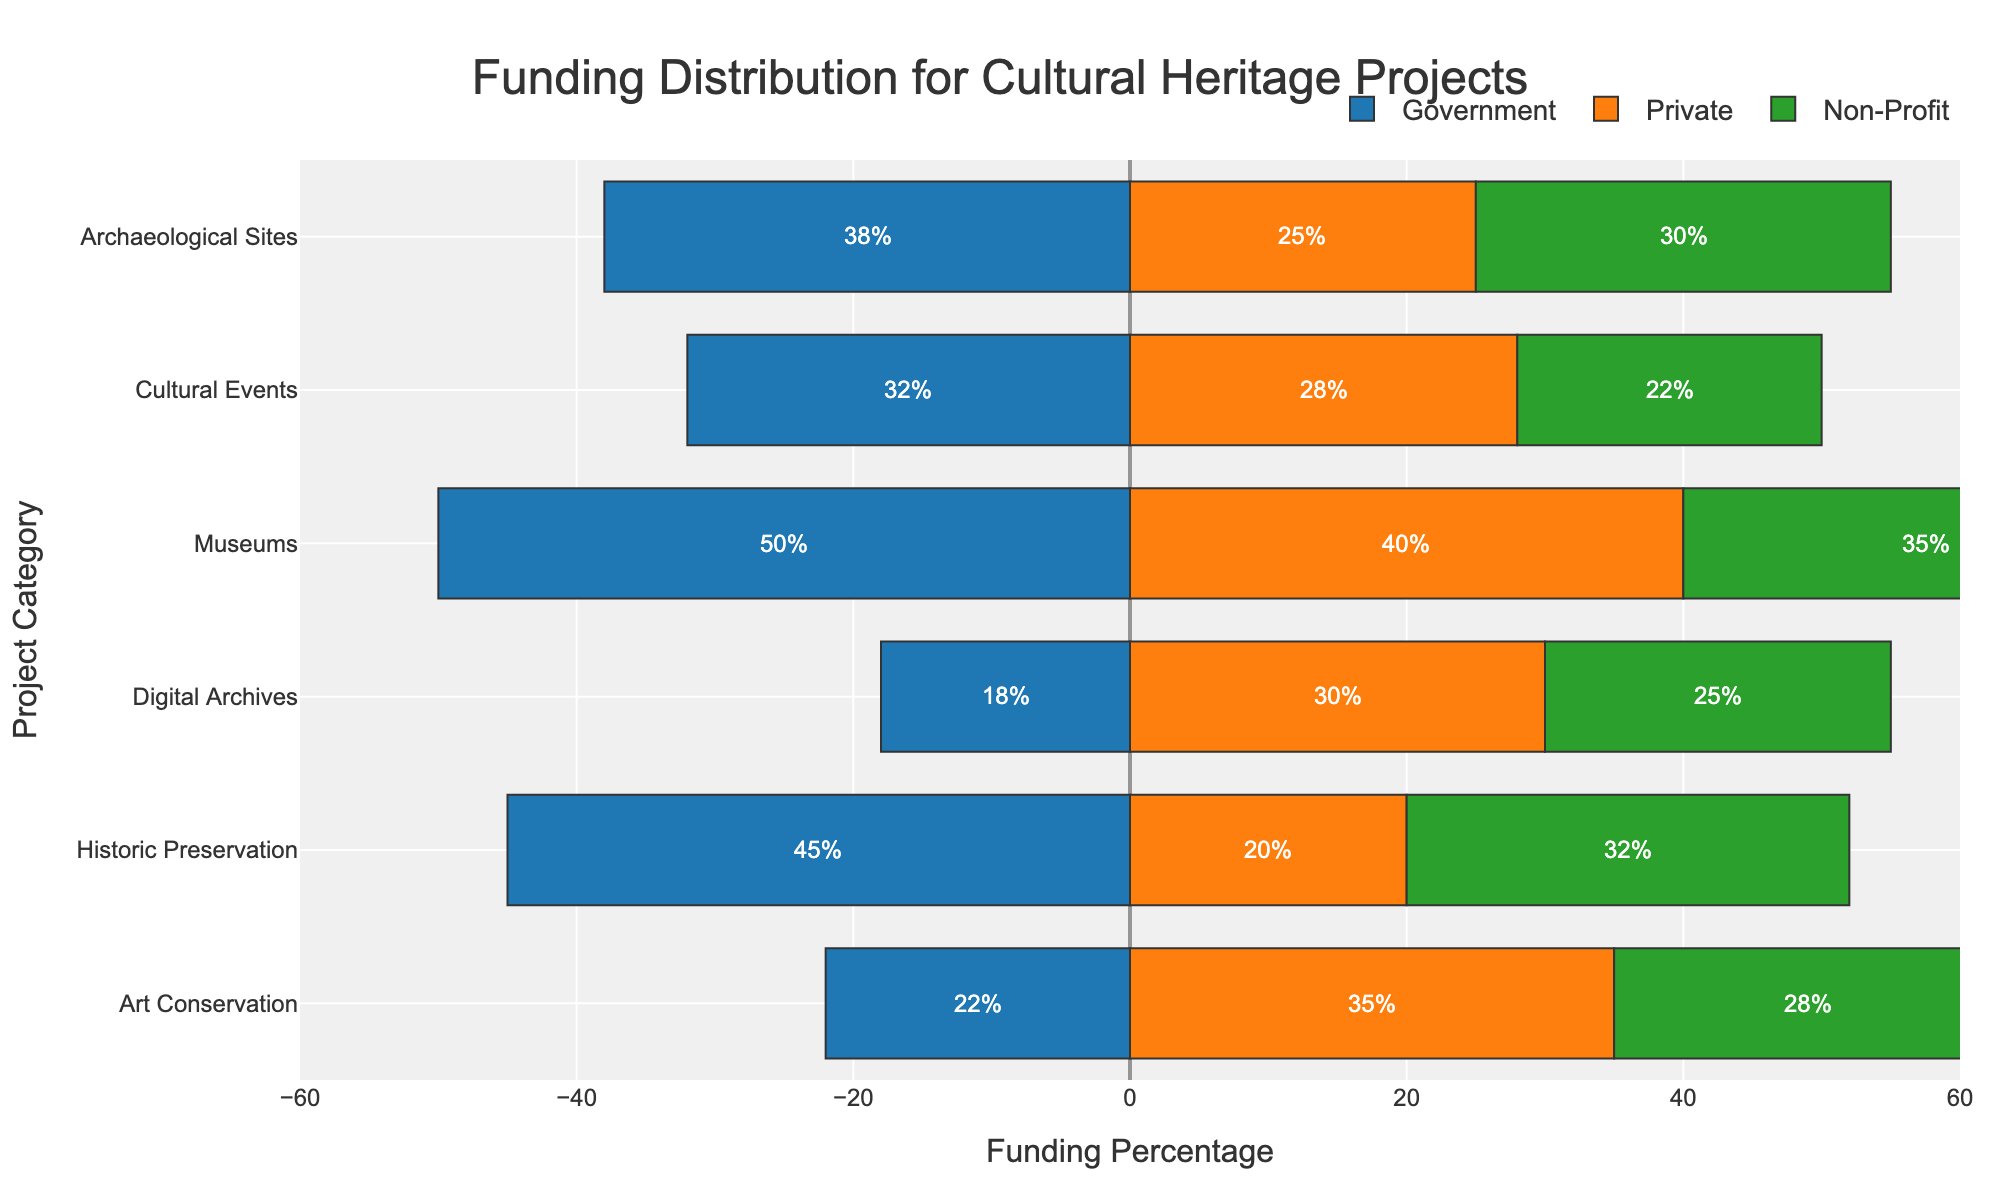Which project category receives the highest percentage of government funding? To determine the project category that receives the highest percentage of government funding, find the category with the longest negative bar (since government funding is represented with a negative value). The category with the longest negative bar is Museums with 50% from the government.
Answer: Museums What is the combined funding percentage for Digital Archives from all sources? Combine the funds from all sources for Digital Archives: Government (18%), Private (30%), and Non-Profit (25%). The sum is 18 + 30 + 25 = 73%.
Answer: 73% Which source contributes the most to Cultural Events funding? Look at the lengths of the orange (Private), blue (Government), and green (Non-Profit) bars for Cultural Events. The longest bar is the Government with 32%.
Answer: Government How much more private funding does Museums receive compared to Art Conservation? Compare the lengths of the orange (Private) bars for Museums (40%) and Art Conservation (35%). The difference is 40 - 35 = 5%.
Answer: 5% Which project category has an equal amount of funding from International and Local sources? Identify the project category where the International and Local percentages are equal by comparing the respective values for each category. For Art Conservation, International and Local funding are both 13%.
Answer: Art Conservation Is the sum of State funding greater for Historic Preservation or Art Conservation? Sum the State funding for both categories: Historic Preservation (30%) and Art Conservation (15%). Historic Preservation has higher State funding.
Answer: Historic Preservation Which project category has the smallest difference between the funding percentages from Federal and Corporates sources? Calculate the absolute difference between Federal and Corporates percentages for each category and identify the minimum. The smallest difference is in Museums with a difference of 10% (35% - 25%).
Answer: Museums In which category does Non-Profit funding exceed Government funding? Compare the green (Non-Profit) bars with the blue (Government) bars for each category. Non-Profit exceeds Government funding in Art Conservation with Non-Profit at 28% and Government at 22%.
Answer: Art Conservation Which two categories receive the same percentage of funding from Foundations? Look at the percentages for Foundations across all categories; match the categories with identical percentages. Both Art Conservation and Museums receive 15% of their funding from Foundations.
Answer: Art Conservation and Museums 